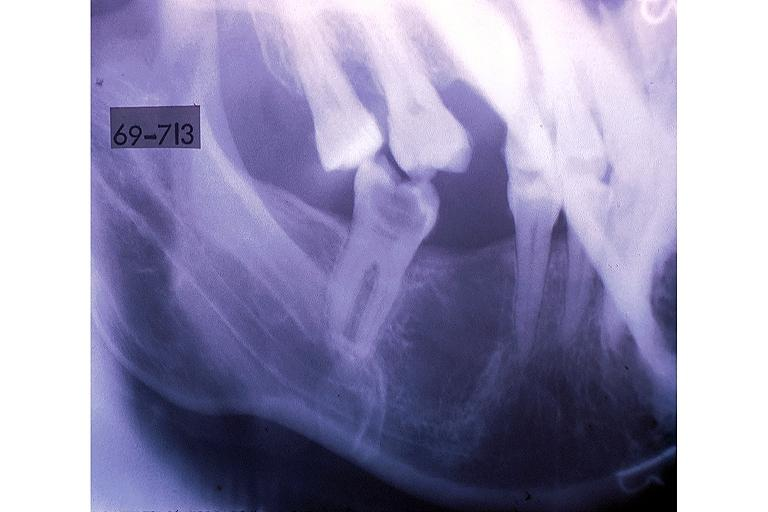s notochord present?
Answer the question using a single word or phrase. No 